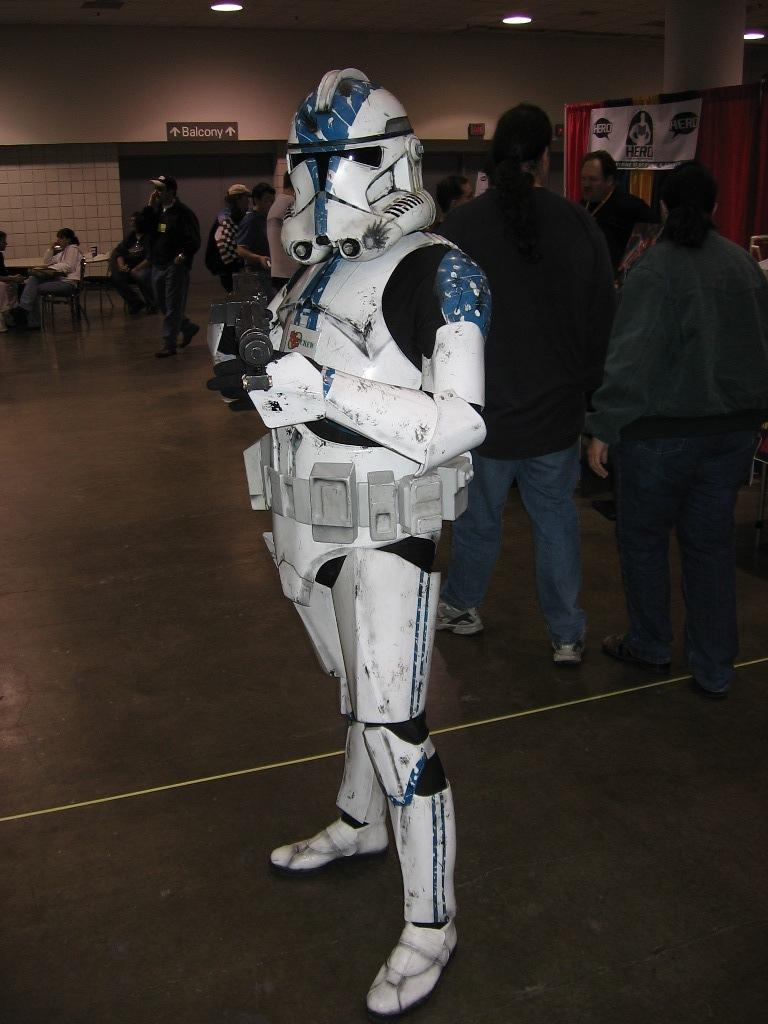Who is the main subject in the image? There is a man in the image. What is the man wearing? The man is wearing a fashion dress. Are there any other people visible in the image? Yes, there are people walking behind the man. What type of whip is the man using to control the animals in the image? There is no whip or animals present in the image; it features a man wearing a fashion dress with people walking behind him. 